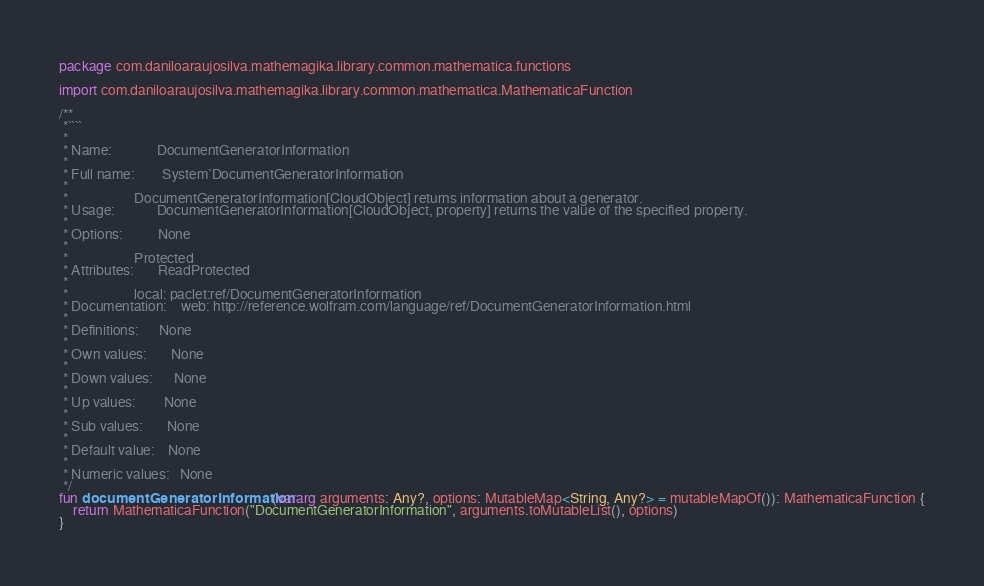<code> <loc_0><loc_0><loc_500><loc_500><_Kotlin_>package com.daniloaraujosilva.mathemagika.library.common.mathematica.functions

import com.daniloaraujosilva.mathemagika.library.common.mathematica.MathematicaFunction

/**
 *````
 *
 * Name:             DocumentGeneratorInformation
 *
 * Full name:        System`DocumentGeneratorInformation
 *
 *                   DocumentGeneratorInformation[CloudObject] returns information about a generator.
 * Usage:            DocumentGeneratorInformation[CloudObject, property] returns the value of the specified property.
 *
 * Options:          None
 *
 *                   Protected
 * Attributes:       ReadProtected
 *
 *                   local: paclet:ref/DocumentGeneratorInformation
 * Documentation:    web: http://reference.wolfram.com/language/ref/DocumentGeneratorInformation.html
 *
 * Definitions:      None
 *
 * Own values:       None
 *
 * Down values:      None
 *
 * Up values:        None
 *
 * Sub values:       None
 *
 * Default value:    None
 *
 * Numeric values:   None
 */
fun documentGeneratorInformation(vararg arguments: Any?, options: MutableMap<String, Any?> = mutableMapOf()): MathematicaFunction {
	return MathematicaFunction("DocumentGeneratorInformation", arguments.toMutableList(), options)
}
</code> 